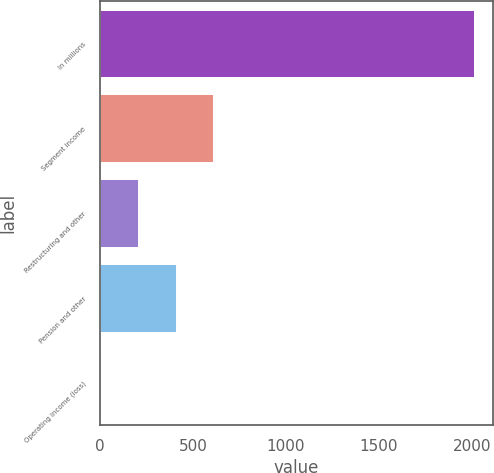<chart> <loc_0><loc_0><loc_500><loc_500><bar_chart><fcel>In millions<fcel>Segment income<fcel>Restructuring and other<fcel>Pension and other<fcel>Operating income (loss)<nl><fcel>2012<fcel>606.96<fcel>205.52<fcel>406.24<fcel>4.8<nl></chart> 